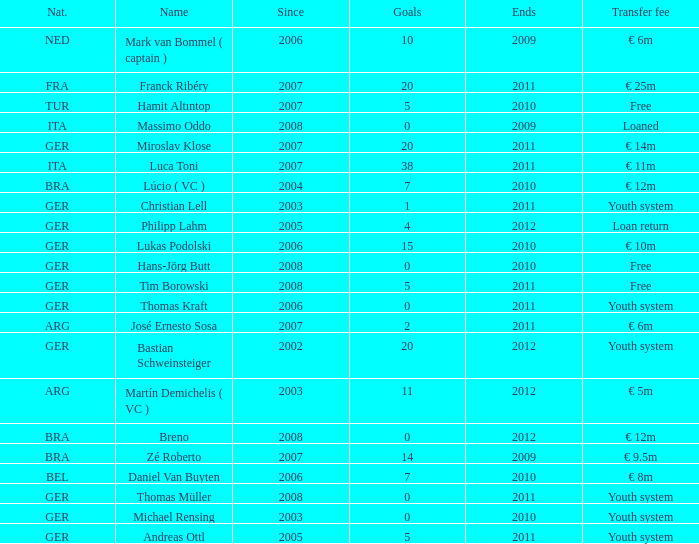What is the total number of ends after 2006 with a nationality of ita and 0 goals? 0.0. 